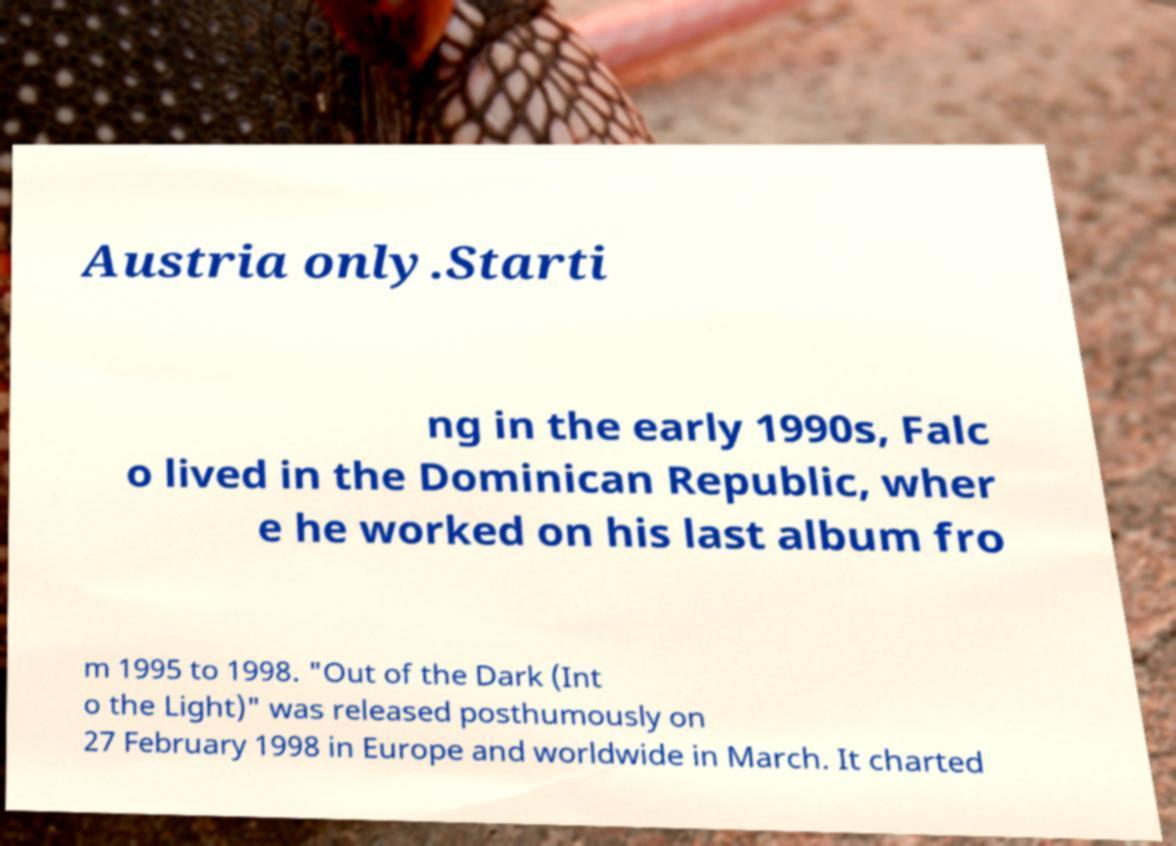What messages or text are displayed in this image? I need them in a readable, typed format. Austria only.Starti ng in the early 1990s, Falc o lived in the Dominican Republic, wher e he worked on his last album fro m 1995 to 1998. "Out of the Dark (Int o the Light)" was released posthumously on 27 February 1998 in Europe and worldwide in March. It charted 